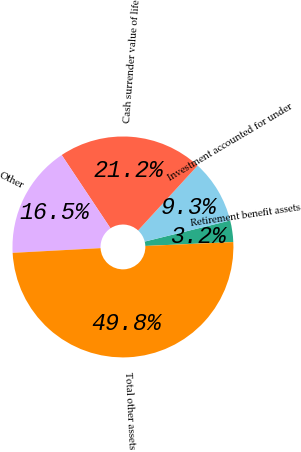Convert chart to OTSL. <chart><loc_0><loc_0><loc_500><loc_500><pie_chart><fcel>Retirement benefit assets<fcel>Investment accounted for under<fcel>Cash surrender value of life<fcel>Other<fcel>Total other assets<nl><fcel>3.15%<fcel>9.33%<fcel>21.17%<fcel>16.5%<fcel>49.85%<nl></chart> 